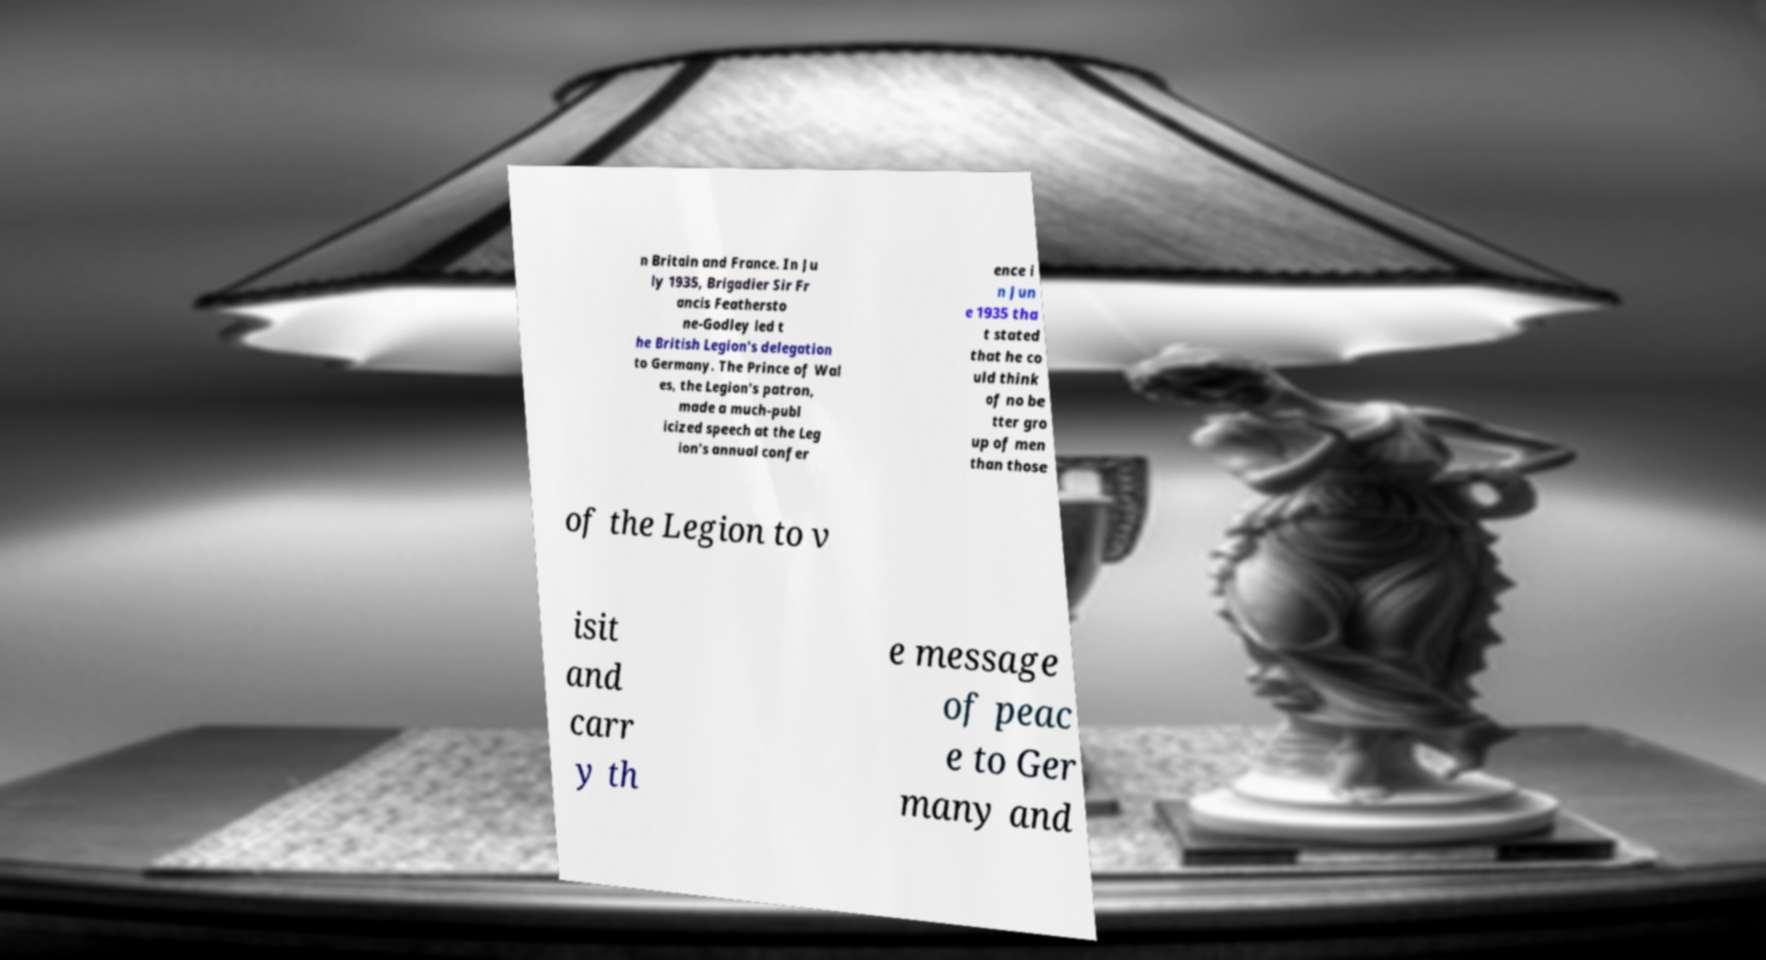Could you extract and type out the text from this image? n Britain and France. In Ju ly 1935, Brigadier Sir Fr ancis Feathersto ne-Godley led t he British Legion's delegation to Germany. The Prince of Wal es, the Legion's patron, made a much-publ icized speech at the Leg ion's annual confer ence i n Jun e 1935 tha t stated that he co uld think of no be tter gro up of men than those of the Legion to v isit and carr y th e message of peac e to Ger many and 